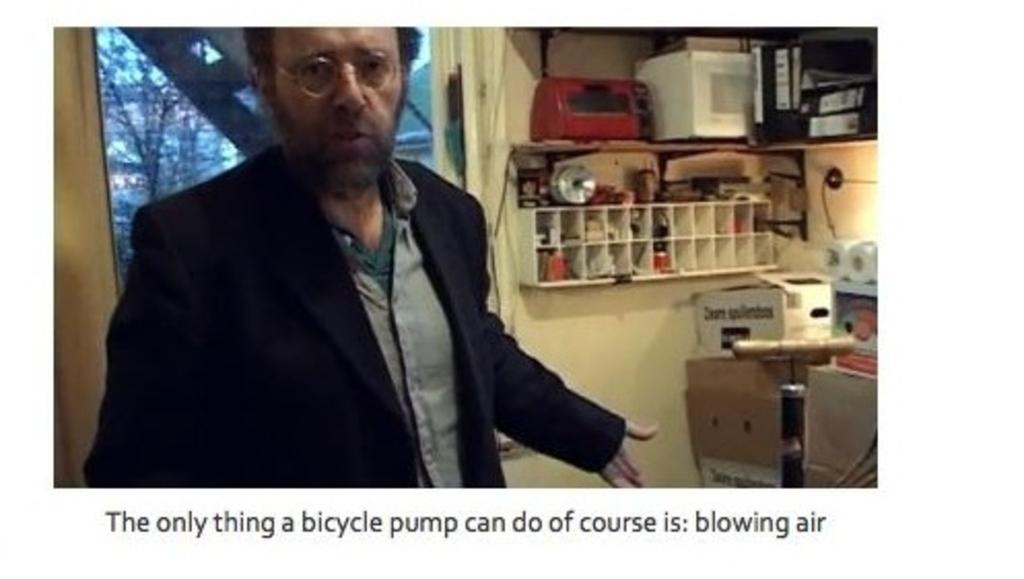What is the main subject of the image? There is a man standing in the image. Where is the man standing? The man is standing on the floor. What can be seen in the background of the image? There are objects arranged in cupboards and trees visible in the background of the image. What else is visible in the background of the image? The sky is visible in the background of the image. What is present at the bottom of the image? There is text at the bottom of the image. How far away is the potato from the man in the image? There is no potato present in the image, so it cannot be determined how far away it might be from the man. 